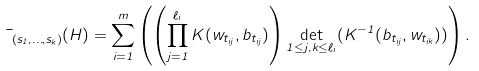<formula> <loc_0><loc_0><loc_500><loc_500>\mu _ { ( s _ { 1 } , \dots , s _ { k } ) } ( H ) = \sum _ { i = 1 } ^ { m } \left ( \left ( \prod _ { j = 1 } ^ { \ell _ { i } } K ( w _ { t _ { i j } } , b _ { t _ { i j } } ) \right ) \det _ { 1 \leq j , k \leq \ell _ { i } } ( K ^ { - 1 } ( b _ { t _ { i j } } , w _ { t _ { i k } } ) ) \right ) .</formula> 